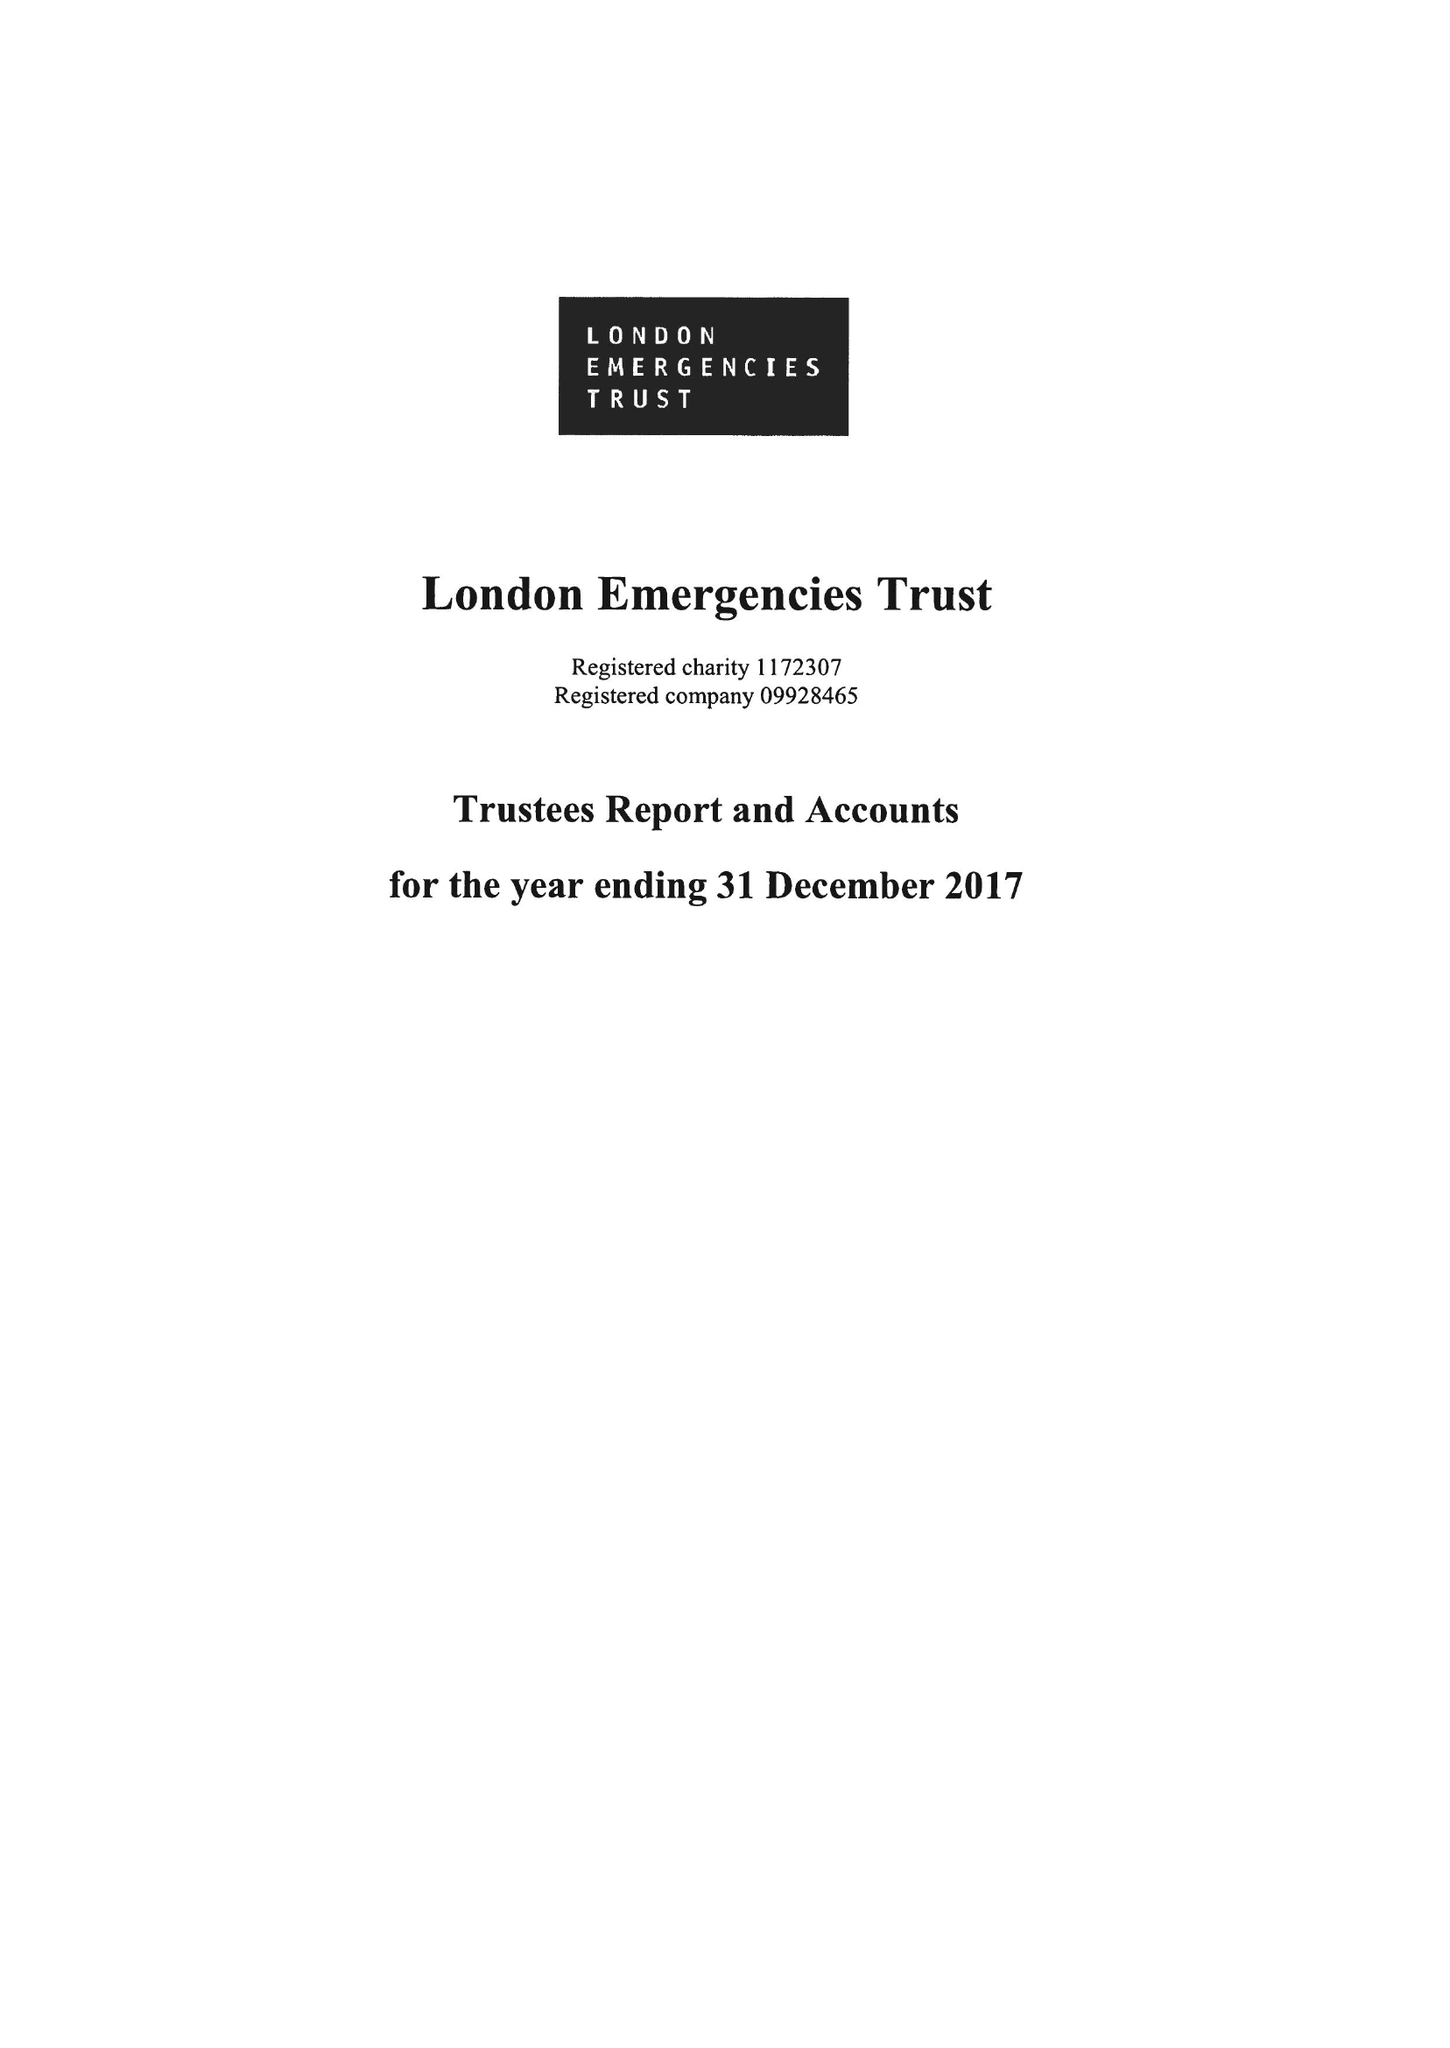What is the value for the address__street_line?
Answer the question using a single word or phrase. 28 COMMERCIAL STREET 